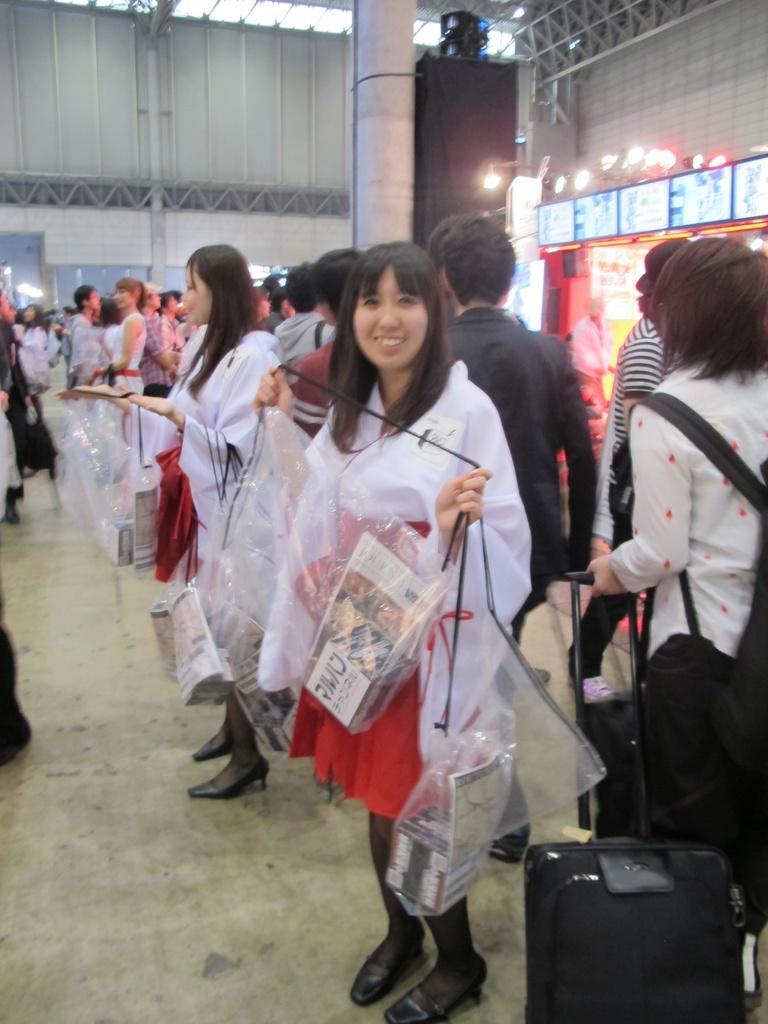Could you give a brief overview of what you see in this image? In this picture we can see a group of people standing on the floor, suitcase, bags, plastic covers with boxes in it, screens, lights, pillar and in the background we can see the wall. 